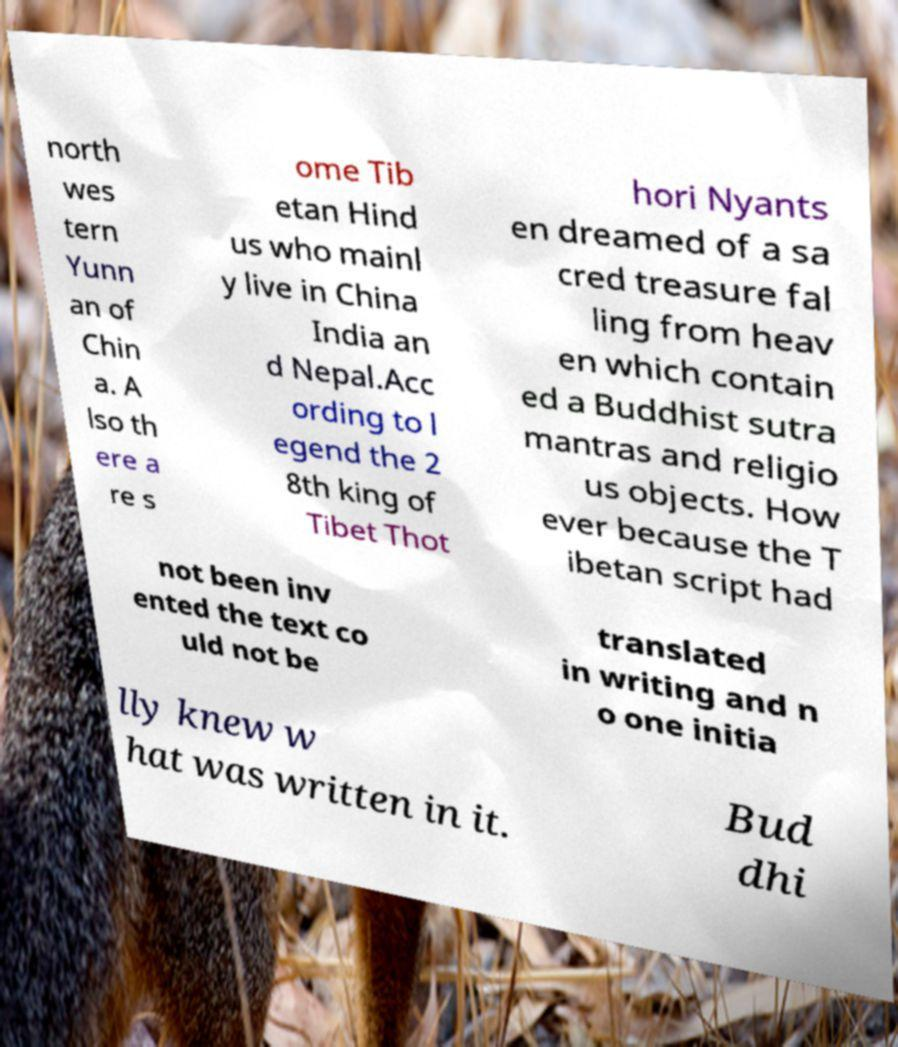Could you extract and type out the text from this image? north wes tern Yunn an of Chin a. A lso th ere a re s ome Tib etan Hind us who mainl y live in China India an d Nepal.Acc ording to l egend the 2 8th king of Tibet Thot hori Nyants en dreamed of a sa cred treasure fal ling from heav en which contain ed a Buddhist sutra mantras and religio us objects. How ever because the T ibetan script had not been inv ented the text co uld not be translated in writing and n o one initia lly knew w hat was written in it. Bud dhi 